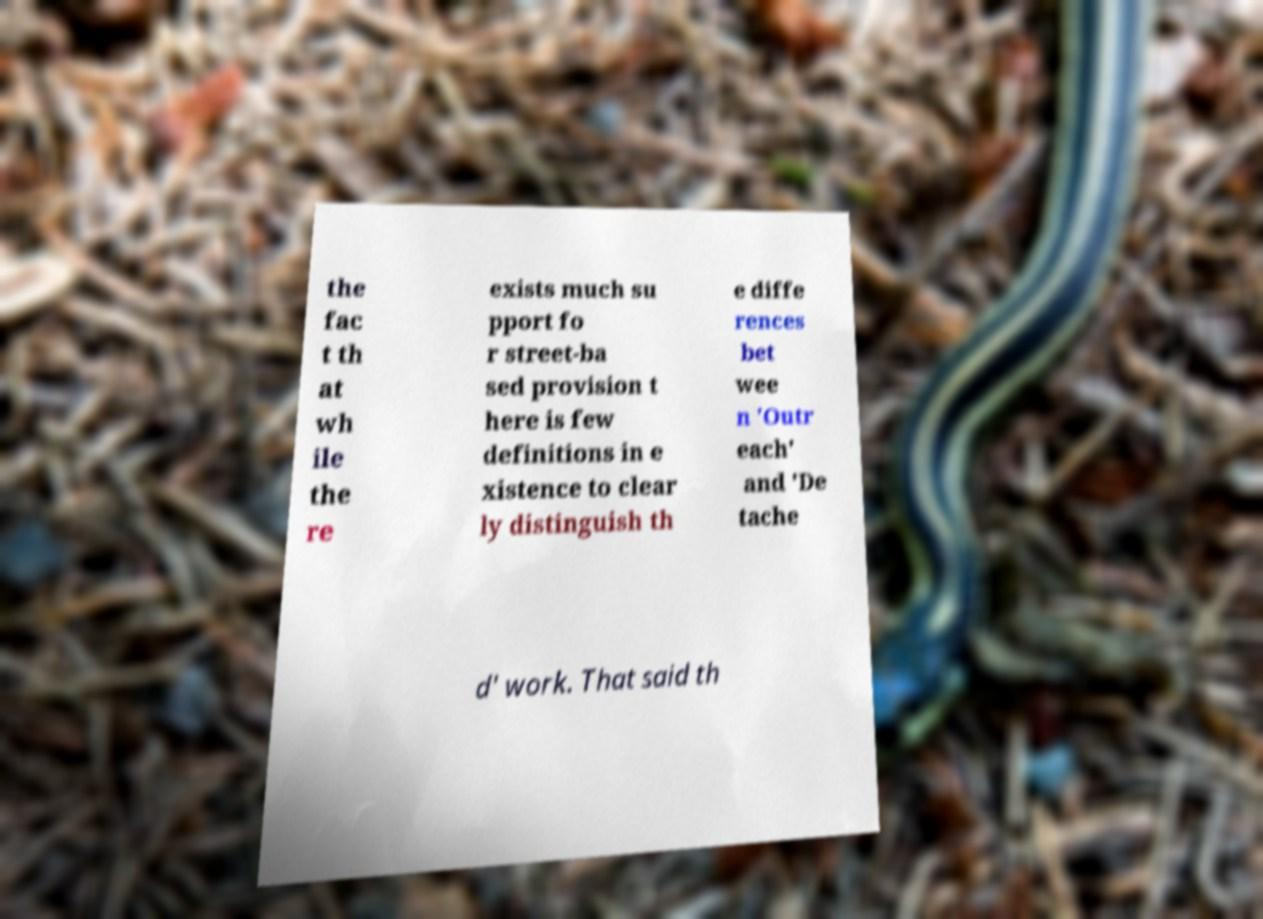Can you read and provide the text displayed in the image?This photo seems to have some interesting text. Can you extract and type it out for me? the fac t th at wh ile the re exists much su pport fo r street-ba sed provision t here is few definitions in e xistence to clear ly distinguish th e diffe rences bet wee n 'Outr each' and 'De tache d' work. That said th 